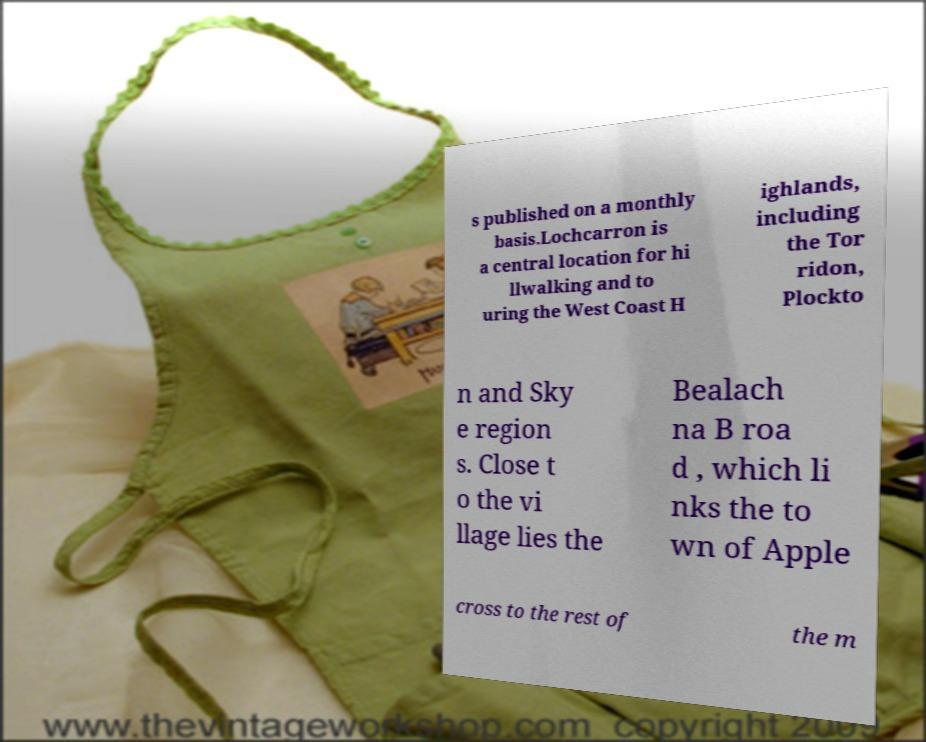For documentation purposes, I need the text within this image transcribed. Could you provide that? s published on a monthly basis.Lochcarron is a central location for hi llwalking and to uring the West Coast H ighlands, including the Tor ridon, Plockto n and Sky e region s. Close t o the vi llage lies the Bealach na B roa d , which li nks the to wn of Apple cross to the rest of the m 